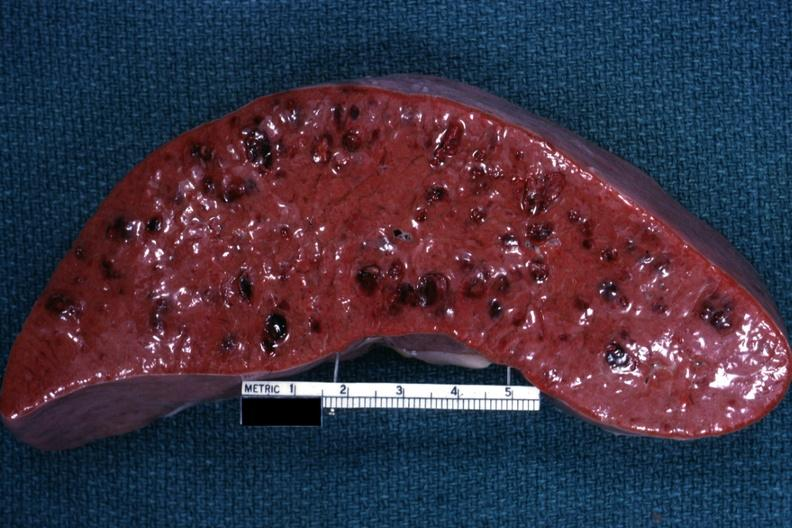what is present?
Answer the question using a single word or phrase. Acute myelogenous leukemia 